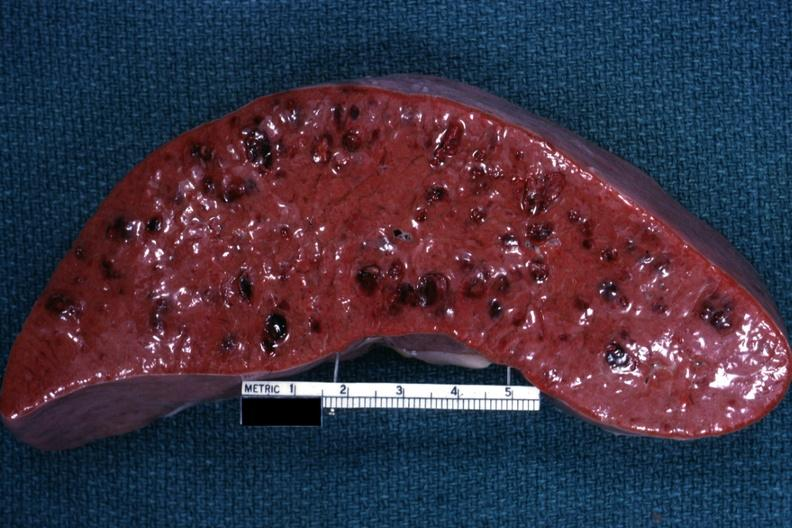what is present?
Answer the question using a single word or phrase. Acute myelogenous leukemia 